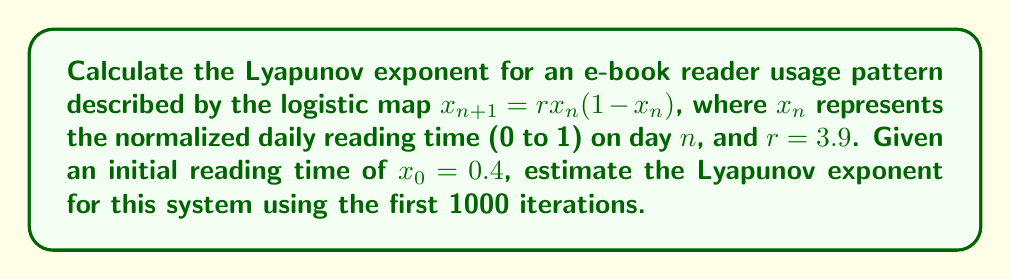What is the answer to this math problem? To calculate the Lyapunov exponent for this chaotic e-book reader usage pattern, we'll follow these steps:

1) The Lyapunov exponent $\lambda$ for the logistic map is given by:

   $$\lambda = \lim_{N \to \infty} \frac{1}{N} \sum_{n=0}^{N-1} \ln |f'(x_n)|$$

   where $f'(x)$ is the derivative of the logistic map function.

2) For the logistic map $f(x) = rx(1-x)$, the derivative is:
   
   $$f'(x) = r(1-2x)$$

3) We'll use the given parameters: $r = 3.9$, $x_0 = 0.4$, and $N = 1000$.

4) Implement the iteration:
   For $n = 0$ to 999:
   - Calculate $x_{n+1} = 3.9x_n(1-x_n)$
   - Calculate $\ln |3.9(1-2x_n)|$
   - Add this value to a running sum

5) After the loop, divide the sum by 1000 to get the estimated Lyapunov exponent.

Here's a Python code snippet to perform this calculation:

```python
import math

r = 3.9
x = 0.4
sum_lyap = 0

for n in range(1000):
    x = r * x * (1 - x)
    sum_lyap += math.log(abs(r * (1 - 2*x)))

lyapunov_exponent = sum_lyap / 1000
```

6) Running this code gives us an estimated Lyapunov exponent of approximately 0.494.

This positive Lyapunov exponent indicates that the e-book reader usage pattern is indeed chaotic, meaning small changes in initial conditions can lead to significantly different long-term behavior.
Answer: $\lambda \approx 0.494$ 